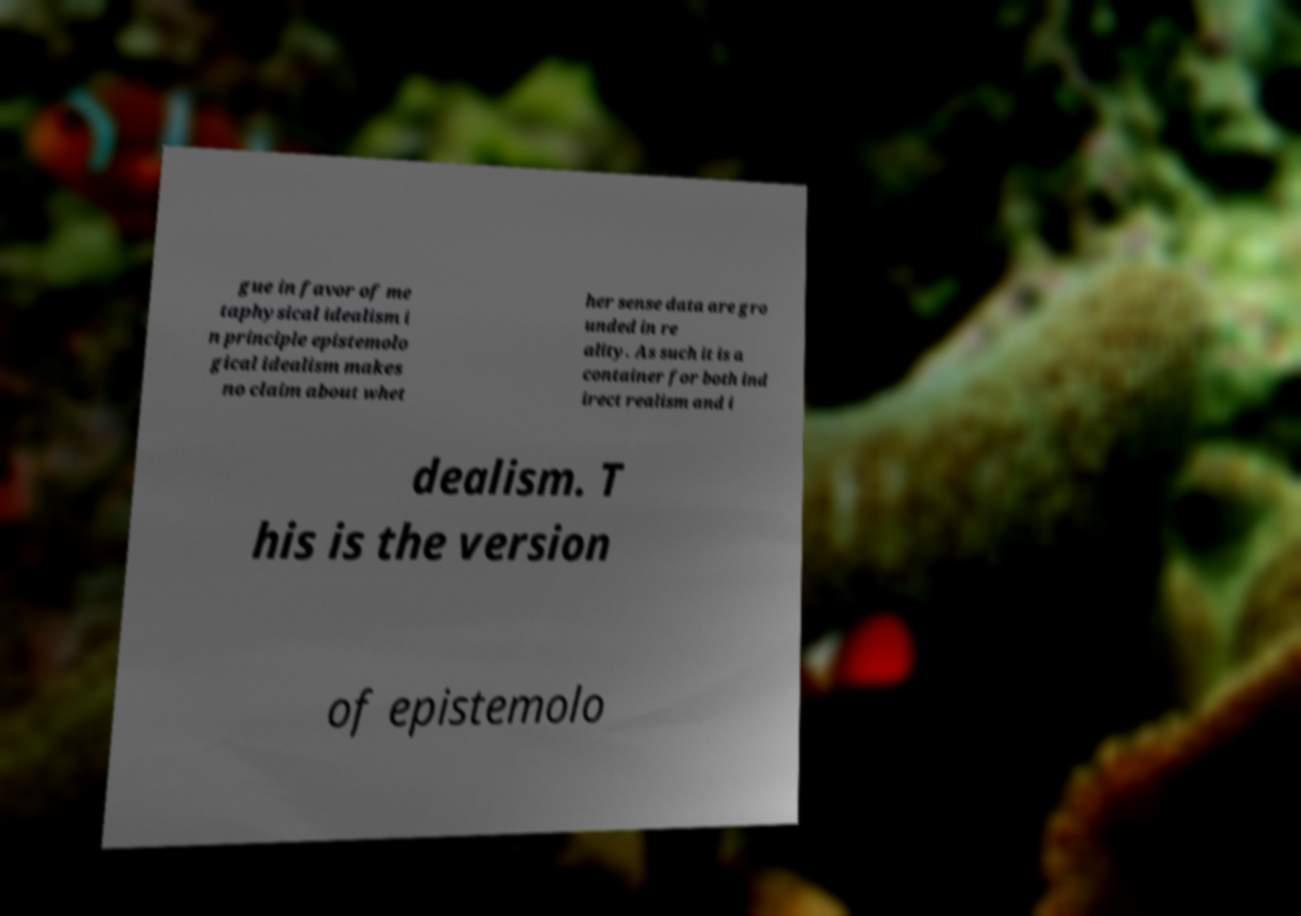What messages or text are displayed in this image? I need them in a readable, typed format. gue in favor of me taphysical idealism i n principle epistemolo gical idealism makes no claim about whet her sense data are gro unded in re ality. As such it is a container for both ind irect realism and i dealism. T his is the version of epistemolo 